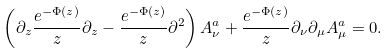Convert formula to latex. <formula><loc_0><loc_0><loc_500><loc_500>\left ( \partial _ { z } \frac { e ^ { - \Phi ( z ) } } { z } \partial _ { z } - \frac { e ^ { - \Phi ( z ) } } { z } \partial ^ { 2 } \right ) A _ { \nu } ^ { a } + \frac { e ^ { - \Phi ( z ) } } { z } \partial _ { \nu } \partial _ { \mu } A _ { \mu } ^ { a } = 0 .</formula> 